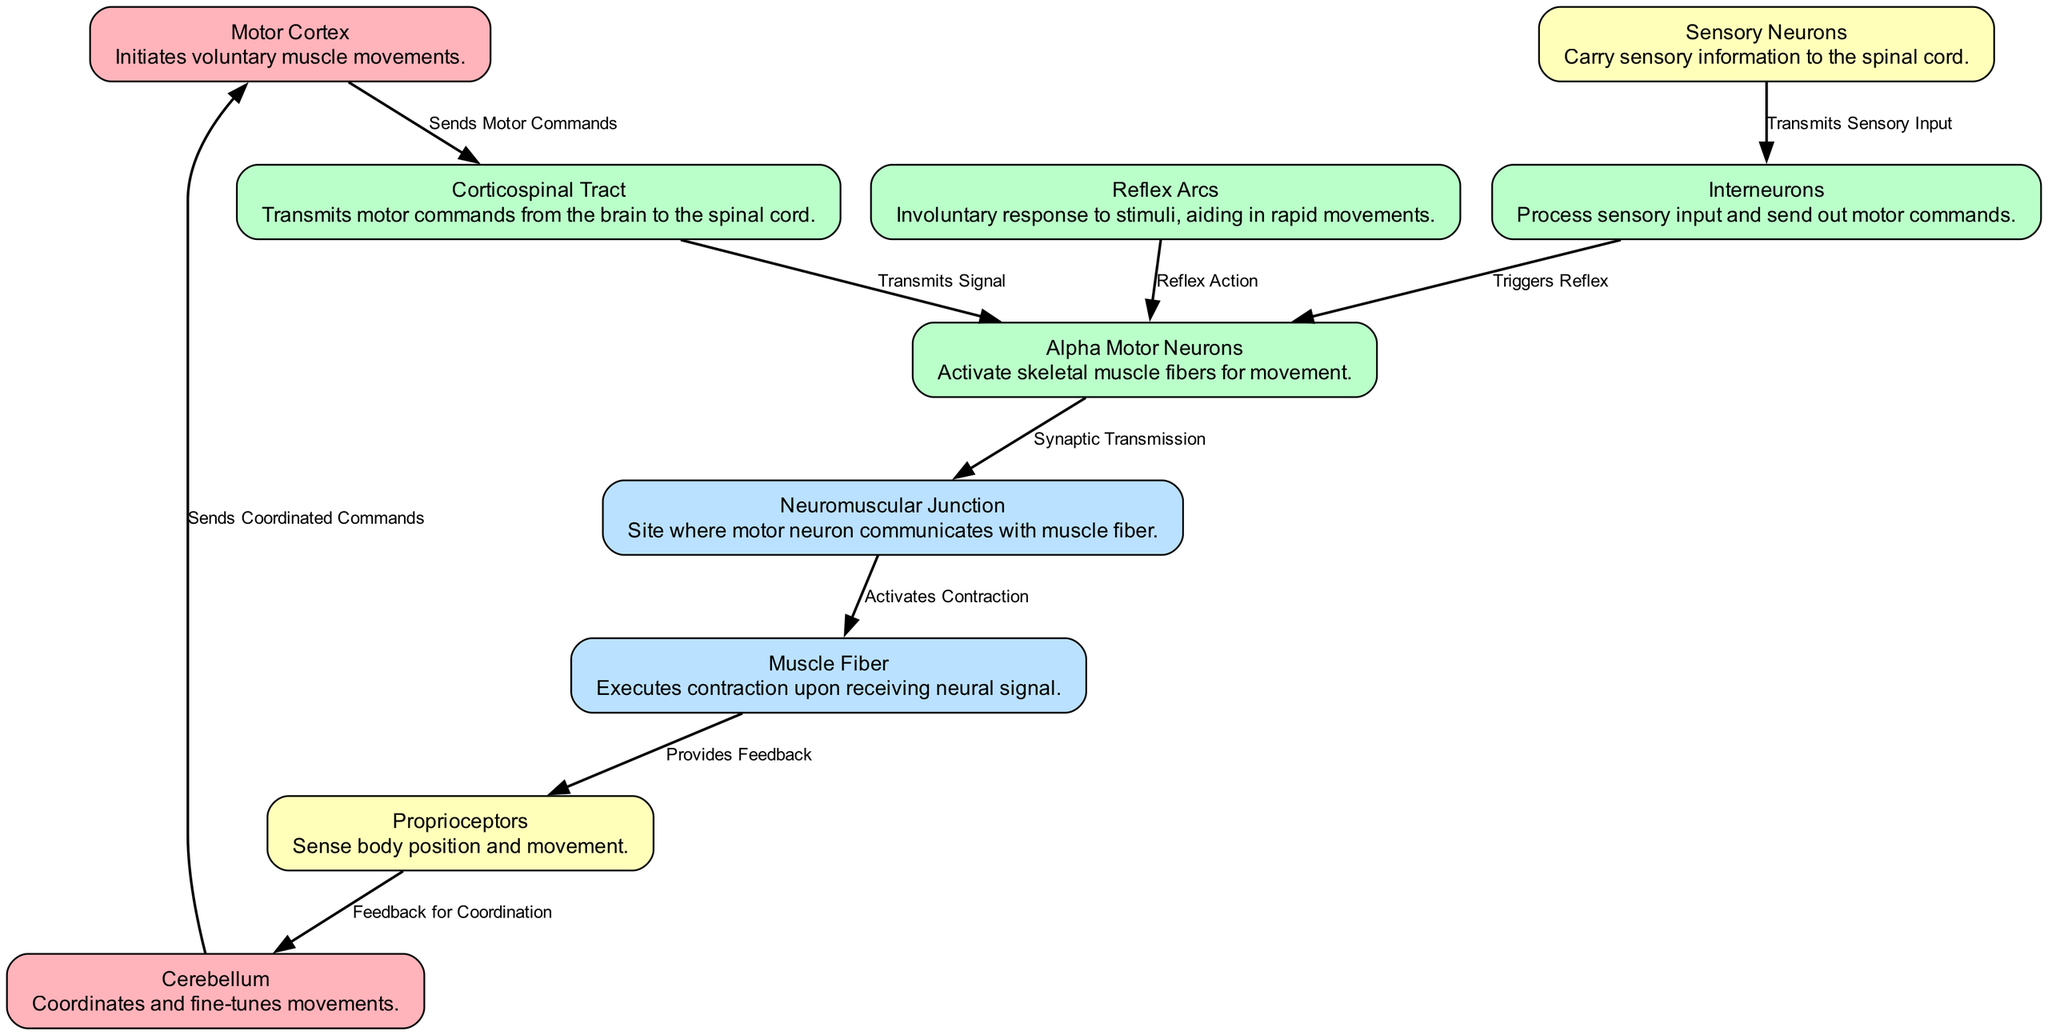How many nodes are in the diagram? The diagram includes a total of 10 nodes representing different components of the neuromuscular system.
Answer: 10 What is the function of the Motor Cortex? The Motor Cortex initiates voluntary muscle movements, which is crucial for actions like batting and throwing in baseball.
Answer: Initiates voluntary muscle movements Which node is responsible for activating skeletal muscle fibers? The Alpha Motor Neurons are specifically responsible for activating skeletal muscle fibers, enabling movement.
Answer: Alpha Motor Neurons What does the Reflex Arc represent in the diagram? The Reflex Arc symbolizes an involuntary response to stimuli, which aids in rapid movements such as reflexive actions during the game.
Answer: Involuntary response to stimuli Which node sends feedback for coordination? Proprioceptors send feedback regarding body position and movement to the Cerebellum for coordination.
Answer: Proprioceptors How does the Cerebellum contribute to motor functions? The Cerebellum coordinates and fine-tunes movements by sending coordinated commands back to the Motor Cortex after receiving feedback from Proprioceptors.
Answer: Coordinates and fine-tunes movements What is the relationship between Sensory Neurons and Interneurons? Sensory Neurons transmit sensory input to Interneurons, which process that information and send out motor commands to Alpha Motor Neurons.
Answer: Transmits sensory input How does the signal flow from the Motor Cortex to Muscle Fiber? The flow starts from the Motor Cortex, which sends motor commands via the Corticospinal Tract to Alpha Motor Neurons, then triggers synaptic transmission at the Neuromuscular Junction, activating Muscle Fibers for contraction.
Answer: Motor commands to Muscle Fibers Which components are involved in the feedback mechanism for movement? The feedback mechanism involves Muscle Fibers providing feedback to Proprioceptors, which then informs the Cerebellum to help coordinate movements effectively.
Answer: Muscle Fibers, Proprioceptors, Cerebellum 